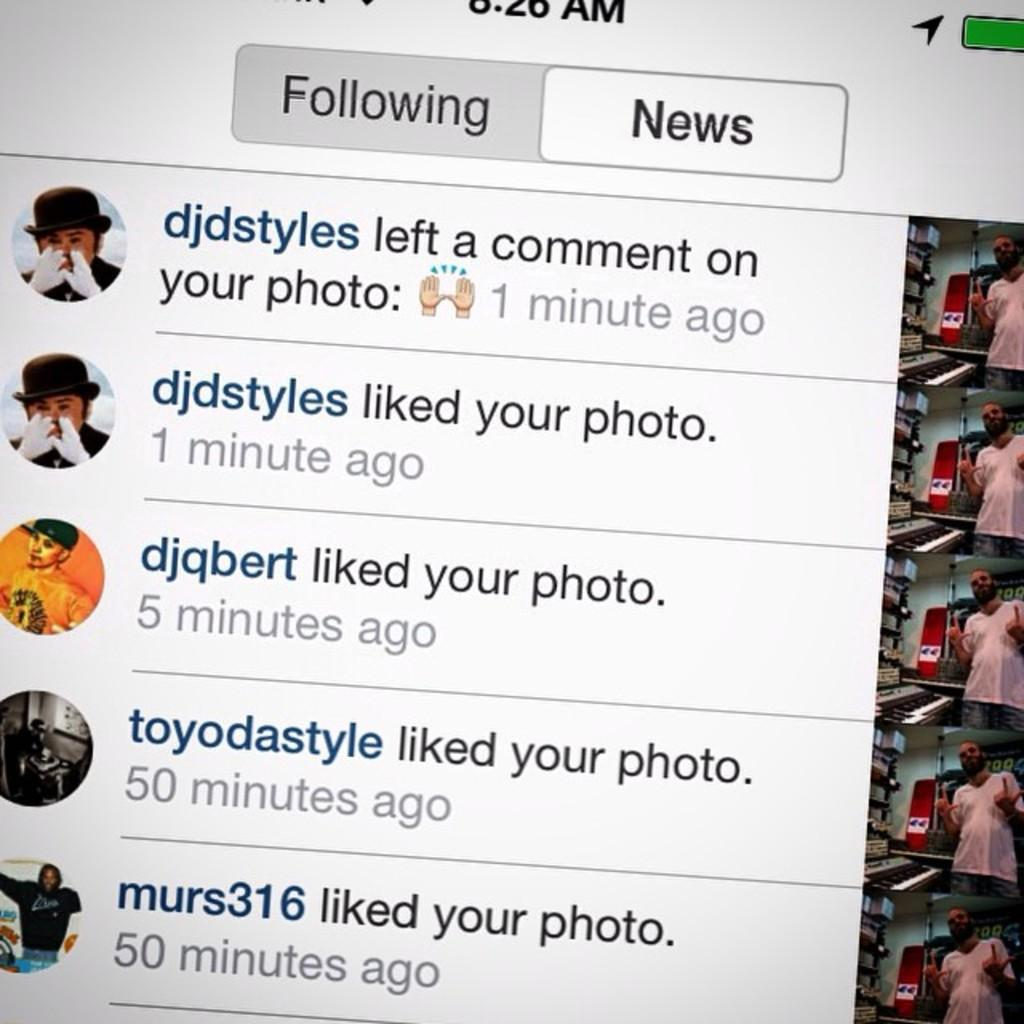What type of images are on the left side of the image? There are profile pictures of many people on the left side of the image. What type of images are on the right side of the image? There are pictures of a man on the right side of the image. What is located in the middle of the image? There is text in the middle of the image. What can be inferred about the origin of the image? The image is a screenshot of a screen. What type of kite is being flown by the man in the image? There is no kite present in the image; it features profile pictures of people and pictures of a man. What rhythm is the text in the middle of the image following? The text in the middle of the image does not have a rhythm, as it is not a musical or poetic composition. 